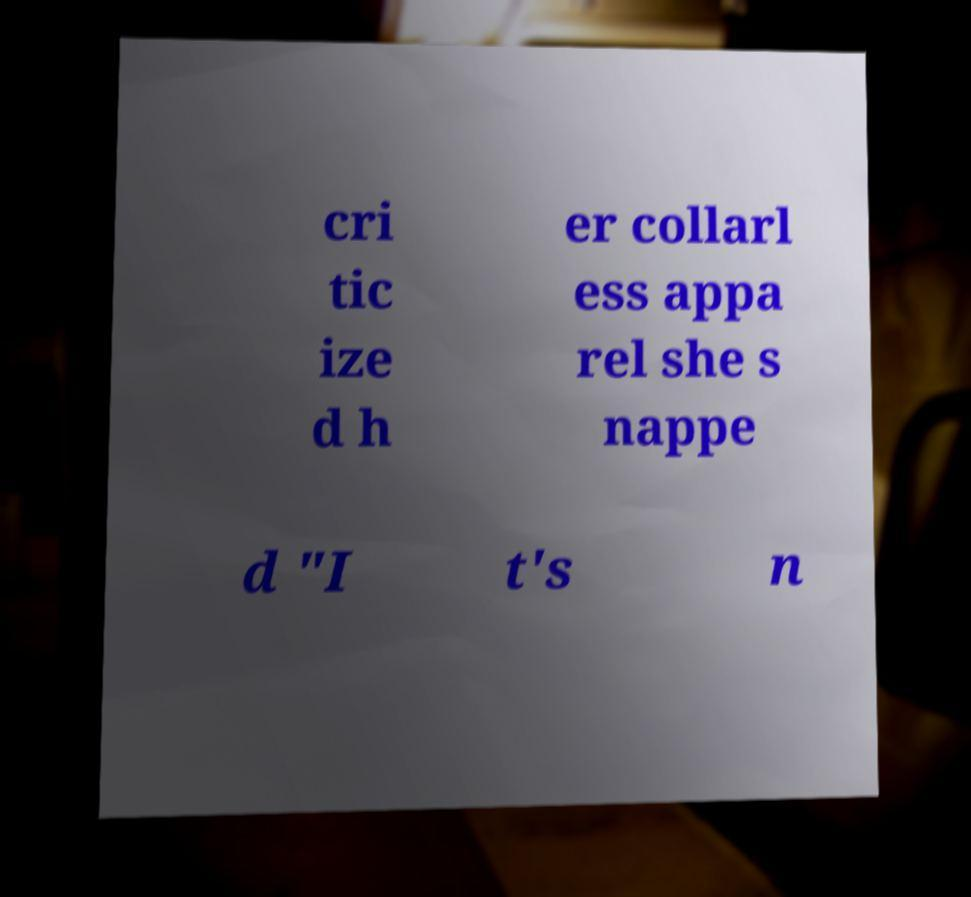For documentation purposes, I need the text within this image transcribed. Could you provide that? cri tic ize d h er collarl ess appa rel she s nappe d "I t's n 